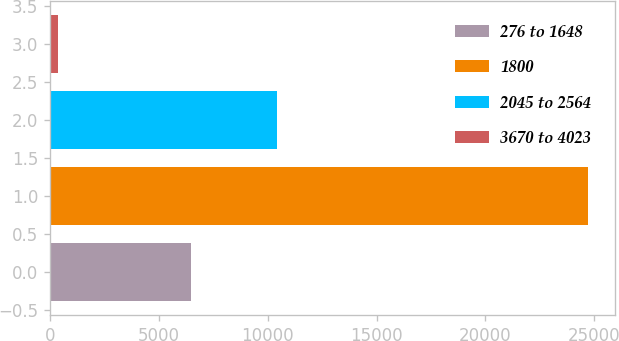Convert chart. <chart><loc_0><loc_0><loc_500><loc_500><bar_chart><fcel>276 to 1648<fcel>1800<fcel>2045 to 2564<fcel>3670 to 4023<nl><fcel>6481<fcel>24706<fcel>10433<fcel>385<nl></chart> 